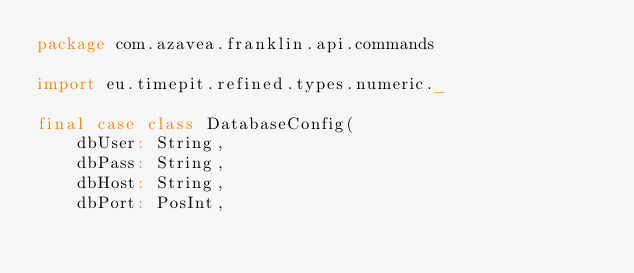Convert code to text. <code><loc_0><loc_0><loc_500><loc_500><_Scala_>package com.azavea.franklin.api.commands

import eu.timepit.refined.types.numeric._

final case class DatabaseConfig(
    dbUser: String,
    dbPass: String,
    dbHost: String,
    dbPort: PosInt,</code> 